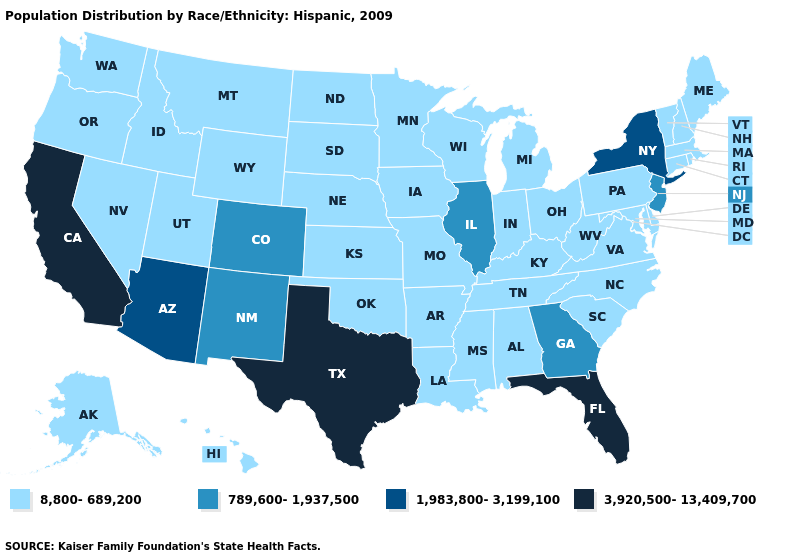Does Montana have the same value as New York?
Be succinct. No. Does Massachusetts have the same value as New York?
Give a very brief answer. No. What is the value of Utah?
Be succinct. 8,800-689,200. How many symbols are there in the legend?
Short answer required. 4. What is the value of Arizona?
Quick response, please. 1,983,800-3,199,100. Does Maryland have the same value as Iowa?
Short answer required. Yes. Name the states that have a value in the range 3,920,500-13,409,700?
Give a very brief answer. California, Florida, Texas. What is the value of Nevada?
Keep it brief. 8,800-689,200. What is the value of Maryland?
Be succinct. 8,800-689,200. What is the value of North Dakota?
Give a very brief answer. 8,800-689,200. Does California have the highest value in the USA?
Concise answer only. Yes. What is the lowest value in the USA?
Short answer required. 8,800-689,200. Among the states that border Wyoming , which have the lowest value?
Be succinct. Idaho, Montana, Nebraska, South Dakota, Utah. Does New York have the lowest value in the Northeast?
Be succinct. No. Does the first symbol in the legend represent the smallest category?
Short answer required. Yes. 